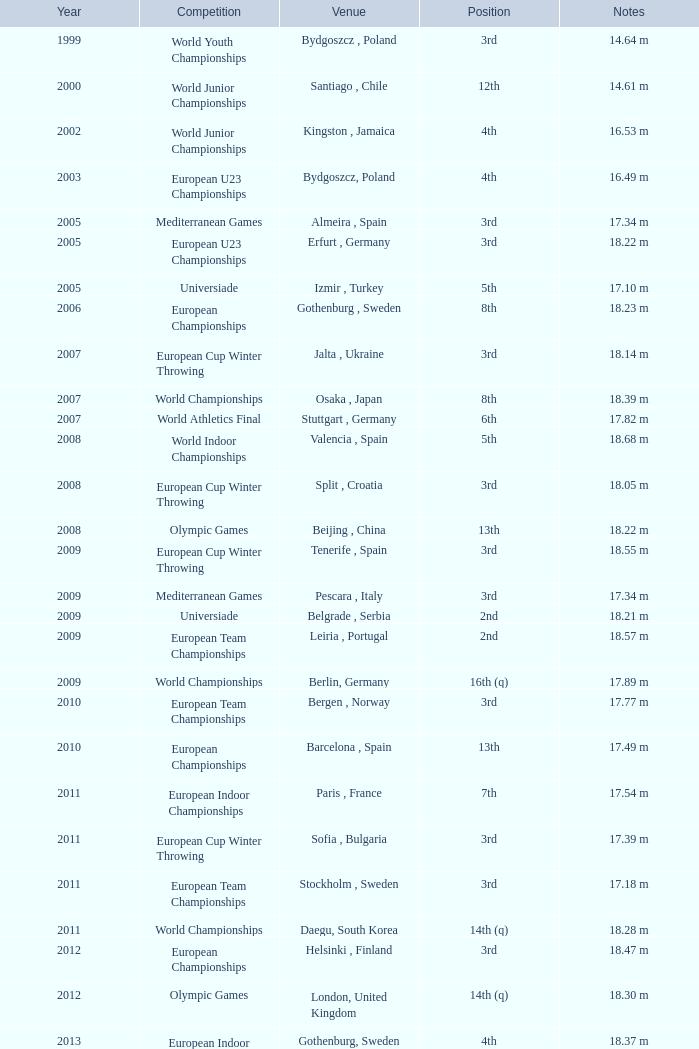What are the notes for bydgoszcz, Poland? 14.64 m, 16.49 m. 